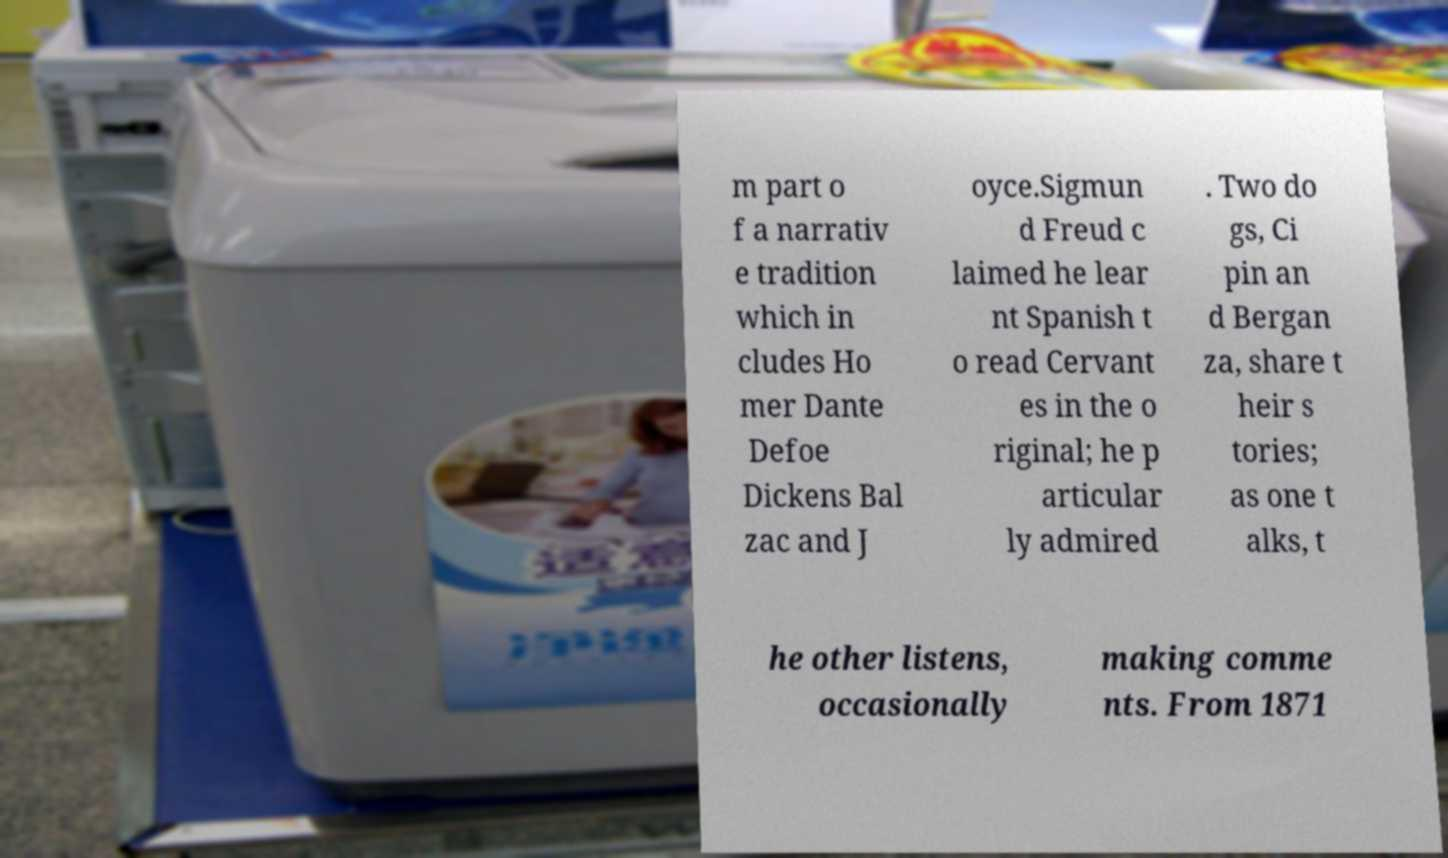There's text embedded in this image that I need extracted. Can you transcribe it verbatim? m part o f a narrativ e tradition which in cludes Ho mer Dante Defoe Dickens Bal zac and J oyce.Sigmun d Freud c laimed he lear nt Spanish t o read Cervant es in the o riginal; he p articular ly admired . Two do gs, Ci pin an d Bergan za, share t heir s tories; as one t alks, t he other listens, occasionally making comme nts. From 1871 